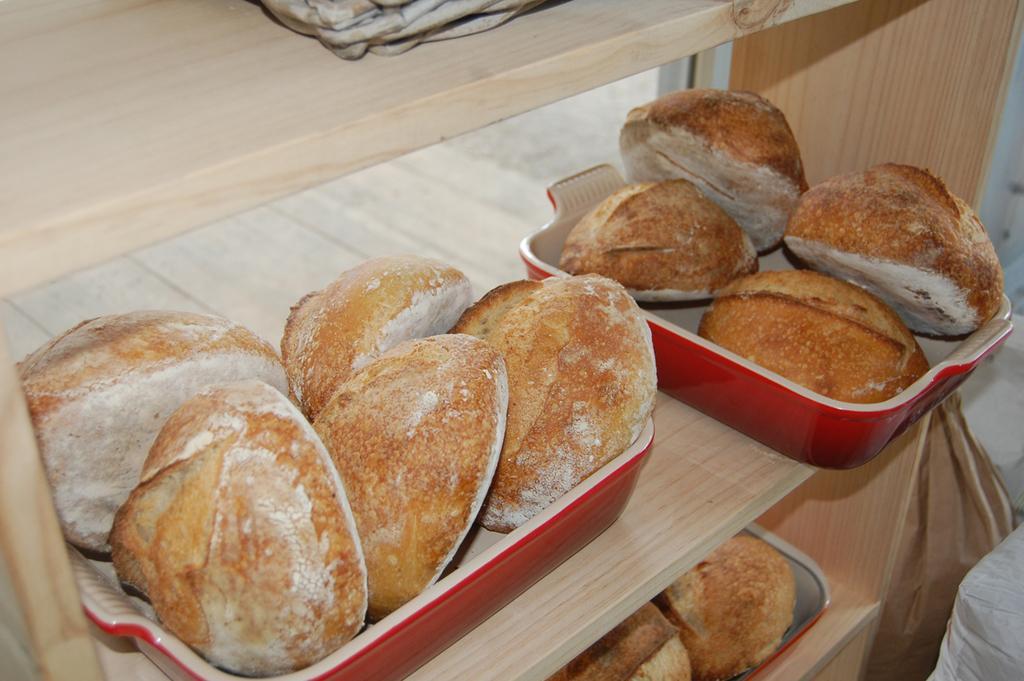How would you summarize this image in a sentence or two? In this image we can see food items in the containers. In the bottom right we can see the bags. 